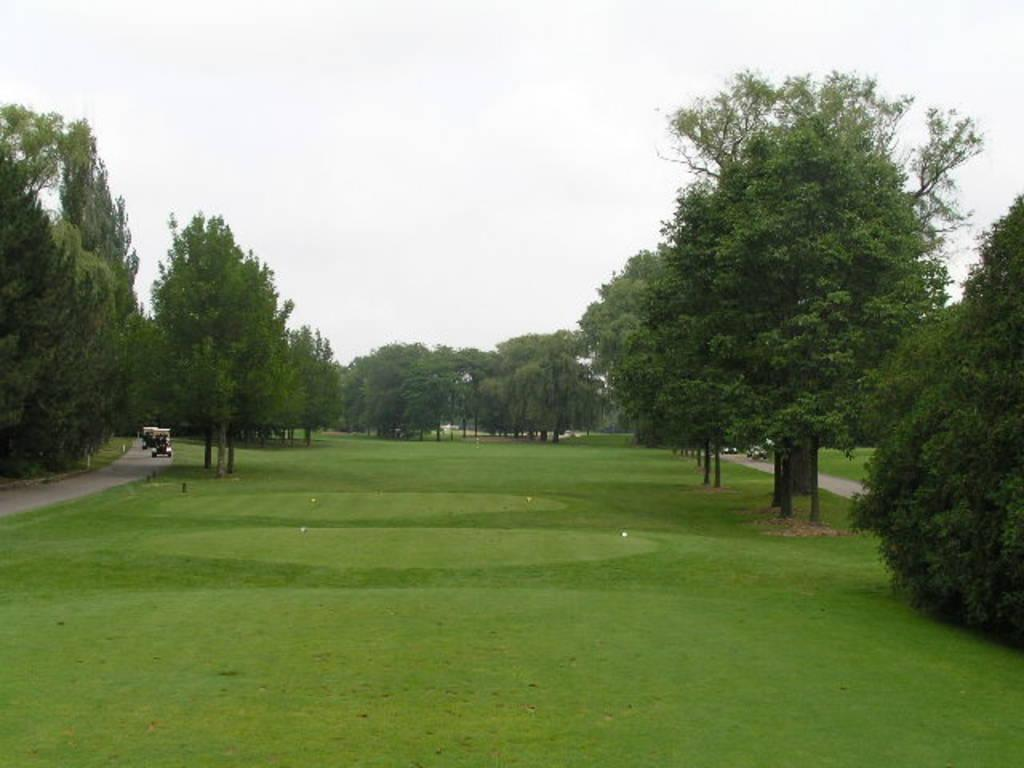What type of vegetation is in the center of the image? There is grass and trees in the center of the image. What can be seen on the road in the image? There are vehicles on the road in the image. What is visible in the background of the image? The sky is visible in the background of the image, and clouds are present. What type of net is being used to catch the mark in the image? There is no mark or net present in the image. What flavor of jam is being spread on the grass in the image? There is no jam or spreading activity depicted in the image. 